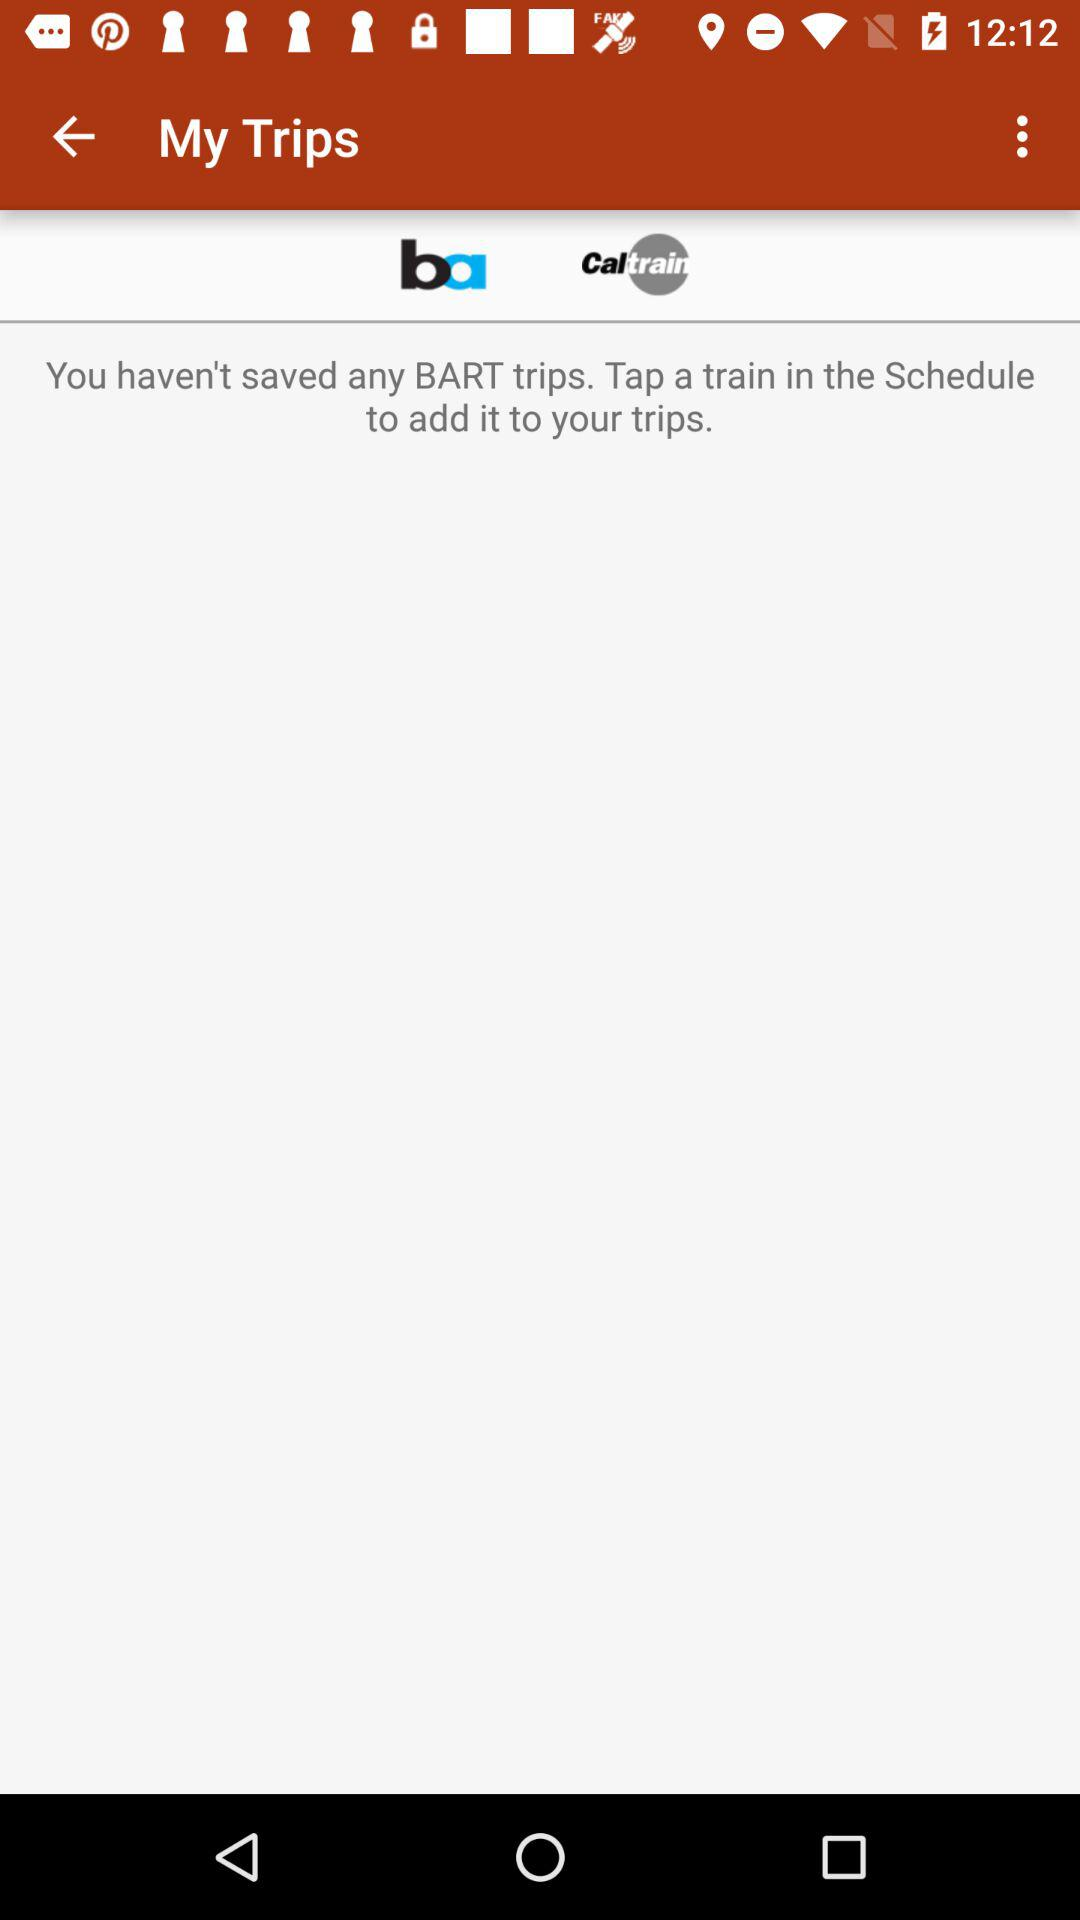How many BART trips have been saved?
Answer the question using a single word or phrase. 0 